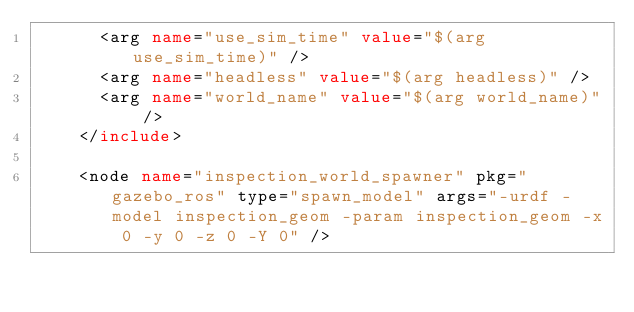Convert code to text. <code><loc_0><loc_0><loc_500><loc_500><_XML_>      <arg name="use_sim_time" value="$(arg use_sim_time)" />
      <arg name="headless" value="$(arg headless)" />
      <arg name="world_name" value="$(arg world_name)" />
    </include>

    <node name="inspection_world_spawner" pkg="gazebo_ros" type="spawn_model" args="-urdf -model inspection_geom -param inspection_geom -x 0 -y 0 -z 0 -Y 0" />
</code> 